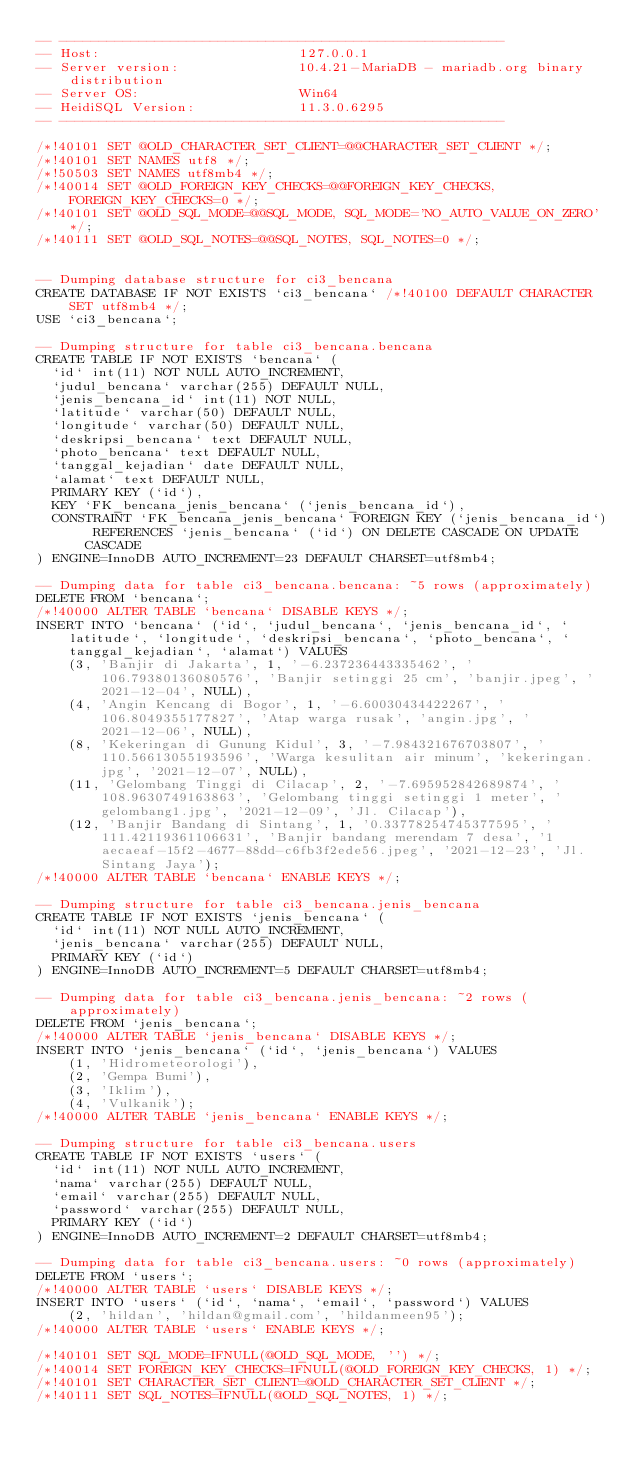<code> <loc_0><loc_0><loc_500><loc_500><_SQL_>-- --------------------------------------------------------
-- Host:                         127.0.0.1
-- Server version:               10.4.21-MariaDB - mariadb.org binary distribution
-- Server OS:                    Win64
-- HeidiSQL Version:             11.3.0.6295
-- --------------------------------------------------------

/*!40101 SET @OLD_CHARACTER_SET_CLIENT=@@CHARACTER_SET_CLIENT */;
/*!40101 SET NAMES utf8 */;
/*!50503 SET NAMES utf8mb4 */;
/*!40014 SET @OLD_FOREIGN_KEY_CHECKS=@@FOREIGN_KEY_CHECKS, FOREIGN_KEY_CHECKS=0 */;
/*!40101 SET @OLD_SQL_MODE=@@SQL_MODE, SQL_MODE='NO_AUTO_VALUE_ON_ZERO' */;
/*!40111 SET @OLD_SQL_NOTES=@@SQL_NOTES, SQL_NOTES=0 */;


-- Dumping database structure for ci3_bencana
CREATE DATABASE IF NOT EXISTS `ci3_bencana` /*!40100 DEFAULT CHARACTER SET utf8mb4 */;
USE `ci3_bencana`;

-- Dumping structure for table ci3_bencana.bencana
CREATE TABLE IF NOT EXISTS `bencana` (
  `id` int(11) NOT NULL AUTO_INCREMENT,
  `judul_bencana` varchar(255) DEFAULT NULL,
  `jenis_bencana_id` int(11) NOT NULL,
  `latitude` varchar(50) DEFAULT NULL,
  `longitude` varchar(50) DEFAULT NULL,
  `deskripsi_bencana` text DEFAULT NULL,
  `photo_bencana` text DEFAULT NULL,
  `tanggal_kejadian` date DEFAULT NULL,
  `alamat` text DEFAULT NULL,
  PRIMARY KEY (`id`),
  KEY `FK_bencana_jenis_bencana` (`jenis_bencana_id`),
  CONSTRAINT `FK_bencana_jenis_bencana` FOREIGN KEY (`jenis_bencana_id`) REFERENCES `jenis_bencana` (`id`) ON DELETE CASCADE ON UPDATE CASCADE
) ENGINE=InnoDB AUTO_INCREMENT=23 DEFAULT CHARSET=utf8mb4;

-- Dumping data for table ci3_bencana.bencana: ~5 rows (approximately)
DELETE FROM `bencana`;
/*!40000 ALTER TABLE `bencana` DISABLE KEYS */;
INSERT INTO `bencana` (`id`, `judul_bencana`, `jenis_bencana_id`, `latitude`, `longitude`, `deskripsi_bencana`, `photo_bencana`, `tanggal_kejadian`, `alamat`) VALUES
	(3, 'Banjir di Jakarta', 1, '-6.237236443335462', '106.79380136080576', 'Banjir setinggi 25 cm', 'banjir.jpeg', '2021-12-04', NULL),
	(4, 'Angin Kencang di Bogor', 1, '-6.60030434422267', '106.8049355177827', 'Atap warga rusak', 'angin.jpg', '2021-12-06', NULL),
	(8, 'Kekeringan di Gunung Kidul', 3, '-7.984321676703807', '110.56613055193596', 'Warga kesulitan air minum', 'kekeringan.jpg', '2021-12-07', NULL),
	(11, 'Gelombang Tinggi di Cilacap', 2, '-7.695952842689874', '108.9630749163863', 'Gelombang tinggi setinggi 1 meter', 'gelombang1.jpg', '2021-12-09', 'Jl. Cilacap'),
	(12, 'Banjir Bandang di Sintang', 1, '0.33778254745377595', '111.42119361106631', 'Banjir bandang merendam 7 desa', '1aecaeaf-15f2-4677-88dd-c6fb3f2ede56.jpeg', '2021-12-23', 'Jl. Sintang Jaya');
/*!40000 ALTER TABLE `bencana` ENABLE KEYS */;

-- Dumping structure for table ci3_bencana.jenis_bencana
CREATE TABLE IF NOT EXISTS `jenis_bencana` (
  `id` int(11) NOT NULL AUTO_INCREMENT,
  `jenis_bencana` varchar(255) DEFAULT NULL,
  PRIMARY KEY (`id`)
) ENGINE=InnoDB AUTO_INCREMENT=5 DEFAULT CHARSET=utf8mb4;

-- Dumping data for table ci3_bencana.jenis_bencana: ~2 rows (approximately)
DELETE FROM `jenis_bencana`;
/*!40000 ALTER TABLE `jenis_bencana` DISABLE KEYS */;
INSERT INTO `jenis_bencana` (`id`, `jenis_bencana`) VALUES
	(1, 'Hidrometeorologi'),
	(2, 'Gempa Bumi'),
	(3, 'Iklim'),
	(4, 'Vulkanik');
/*!40000 ALTER TABLE `jenis_bencana` ENABLE KEYS */;

-- Dumping structure for table ci3_bencana.users
CREATE TABLE IF NOT EXISTS `users` (
  `id` int(11) NOT NULL AUTO_INCREMENT,
  `nama` varchar(255) DEFAULT NULL,
  `email` varchar(255) DEFAULT NULL,
  `password` varchar(255) DEFAULT NULL,
  PRIMARY KEY (`id`)
) ENGINE=InnoDB AUTO_INCREMENT=2 DEFAULT CHARSET=utf8mb4;

-- Dumping data for table ci3_bencana.users: ~0 rows (approximately)
DELETE FROM `users`;
/*!40000 ALTER TABLE `users` DISABLE KEYS */;
INSERT INTO `users` (`id`, `nama`, `email`, `password`) VALUES
	(2, 'hildan', 'hildan@gmail.com', 'hildanmeen95');
/*!40000 ALTER TABLE `users` ENABLE KEYS */;

/*!40101 SET SQL_MODE=IFNULL(@OLD_SQL_MODE, '') */;
/*!40014 SET FOREIGN_KEY_CHECKS=IFNULL(@OLD_FOREIGN_KEY_CHECKS, 1) */;
/*!40101 SET CHARACTER_SET_CLIENT=@OLD_CHARACTER_SET_CLIENT */;
/*!40111 SET SQL_NOTES=IFNULL(@OLD_SQL_NOTES, 1) */;
</code> 